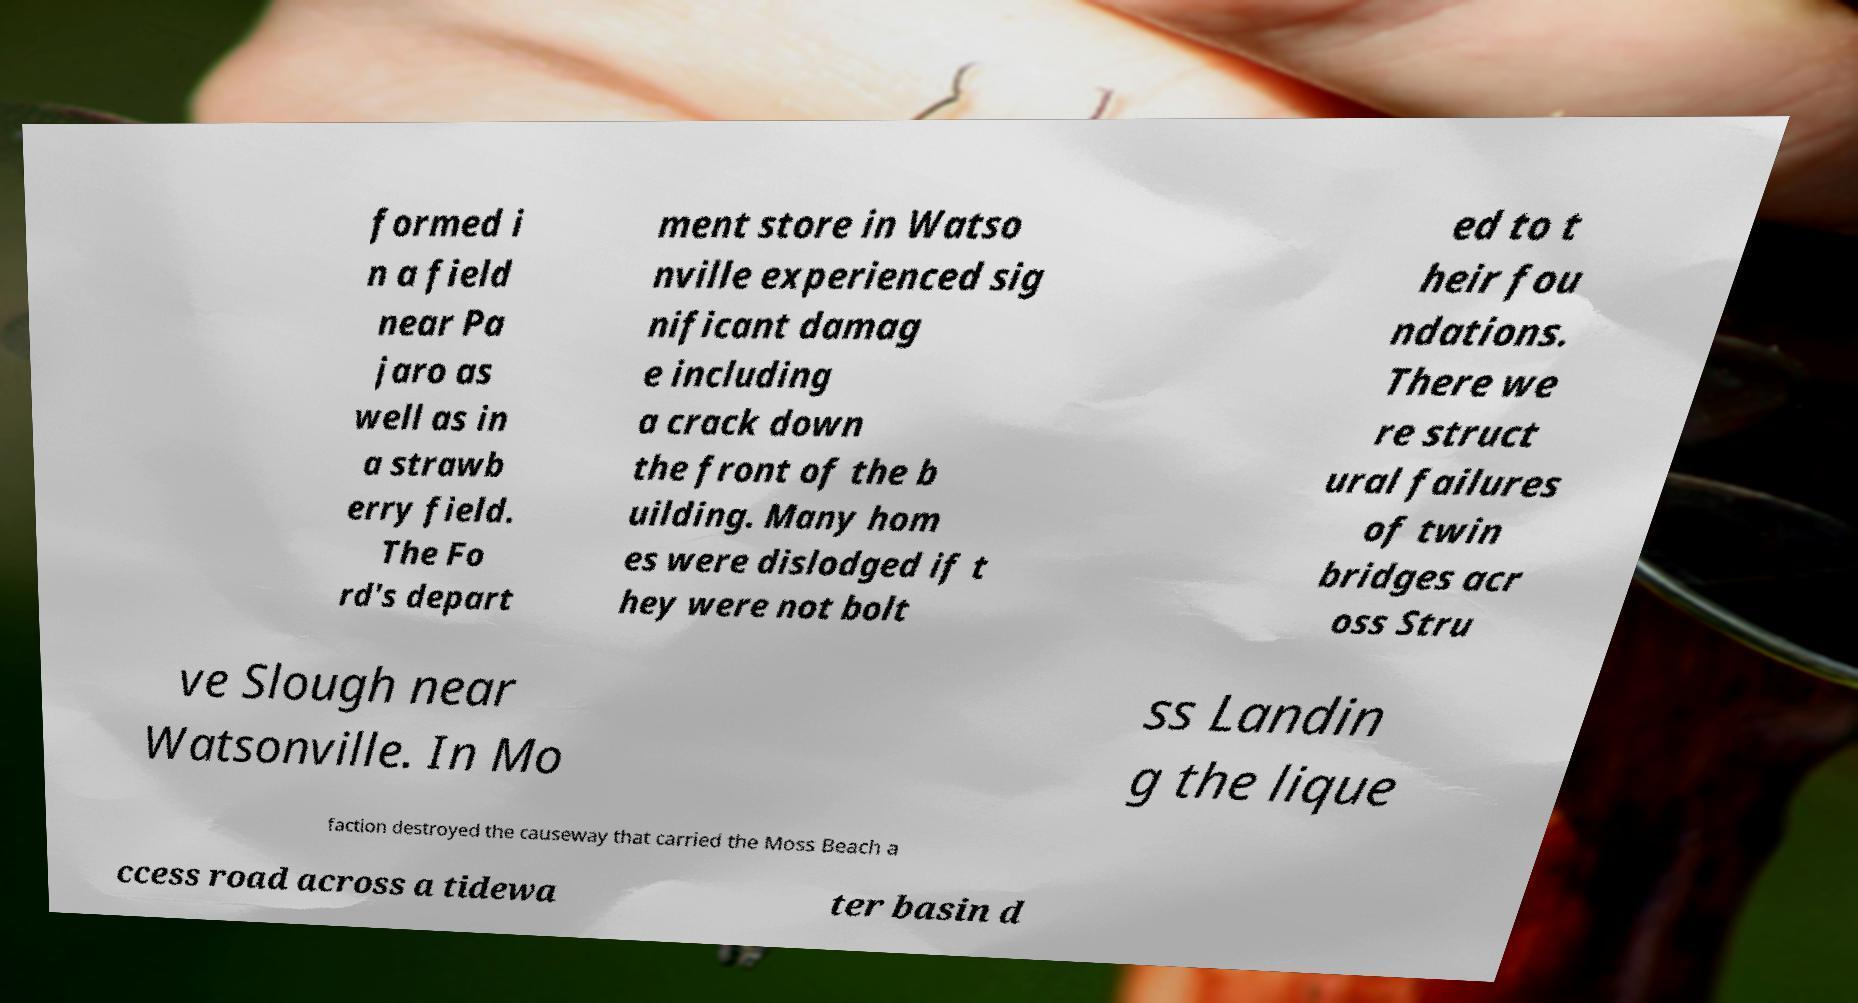Can you accurately transcribe the text from the provided image for me? formed i n a field near Pa jaro as well as in a strawb erry field. The Fo rd's depart ment store in Watso nville experienced sig nificant damag e including a crack down the front of the b uilding. Many hom es were dislodged if t hey were not bolt ed to t heir fou ndations. There we re struct ural failures of twin bridges acr oss Stru ve Slough near Watsonville. In Mo ss Landin g the lique faction destroyed the causeway that carried the Moss Beach a ccess road across a tidewa ter basin d 